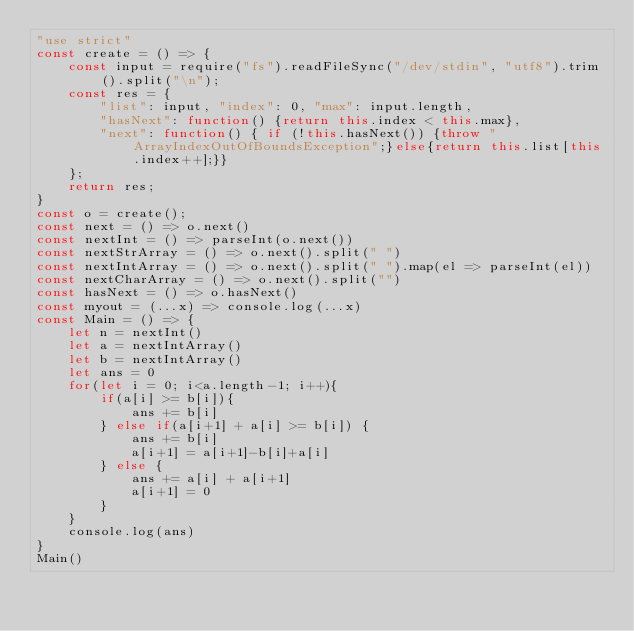Convert code to text. <code><loc_0><loc_0><loc_500><loc_500><_JavaScript_>"use strict"
const create = () => {
    const input = require("fs").readFileSync("/dev/stdin", "utf8").trim().split("\n");
    const res = {
        "list": input, "index": 0, "max": input.length,
        "hasNext": function() {return this.index < this.max},
        "next": function() { if (!this.hasNext()) {throw "ArrayIndexOutOfBoundsException";}else{return this.list[this.index++];}}
    };
    return res;
}
const o = create();
const next = () => o.next()
const nextInt = () => parseInt(o.next())
const nextStrArray = () => o.next().split(" ")
const nextIntArray = () => o.next().split(" ").map(el => parseInt(el))
const nextCharArray = () => o.next().split("")
const hasNext = () => o.hasNext()
const myout = (...x) => console.log(...x)
const Main = () => {
    let n = nextInt()
    let a = nextIntArray()
    let b = nextIntArray()
    let ans = 0
    for(let i = 0; i<a.length-1; i++){
        if(a[i] >= b[i]){
            ans += b[i]
        } else if(a[i+1] + a[i] >= b[i]) {
            ans += b[i]
            a[i+1] = a[i+1]-b[i]+a[i]
        } else {
            ans += a[i] + a[i+1]
            a[i+1] = 0
        }
    }
    console.log(ans)
}
Main()

</code> 